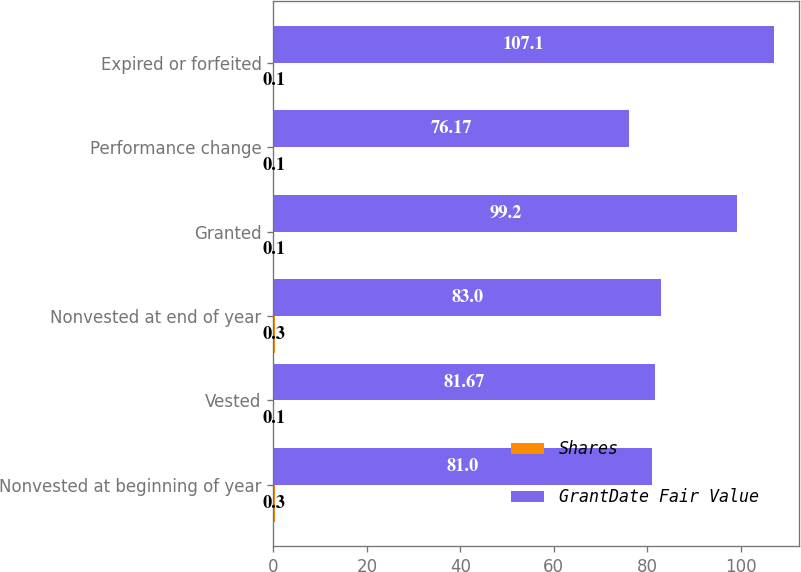Convert chart. <chart><loc_0><loc_0><loc_500><loc_500><stacked_bar_chart><ecel><fcel>Nonvested at beginning of year<fcel>Vested<fcel>Nonvested at end of year<fcel>Granted<fcel>Performance change<fcel>Expired or forfeited<nl><fcel>Shares<fcel>0.3<fcel>0.1<fcel>0.3<fcel>0.1<fcel>0.1<fcel>0.1<nl><fcel>GrantDate Fair Value<fcel>81<fcel>81.67<fcel>83<fcel>99.2<fcel>76.17<fcel>107.1<nl></chart> 